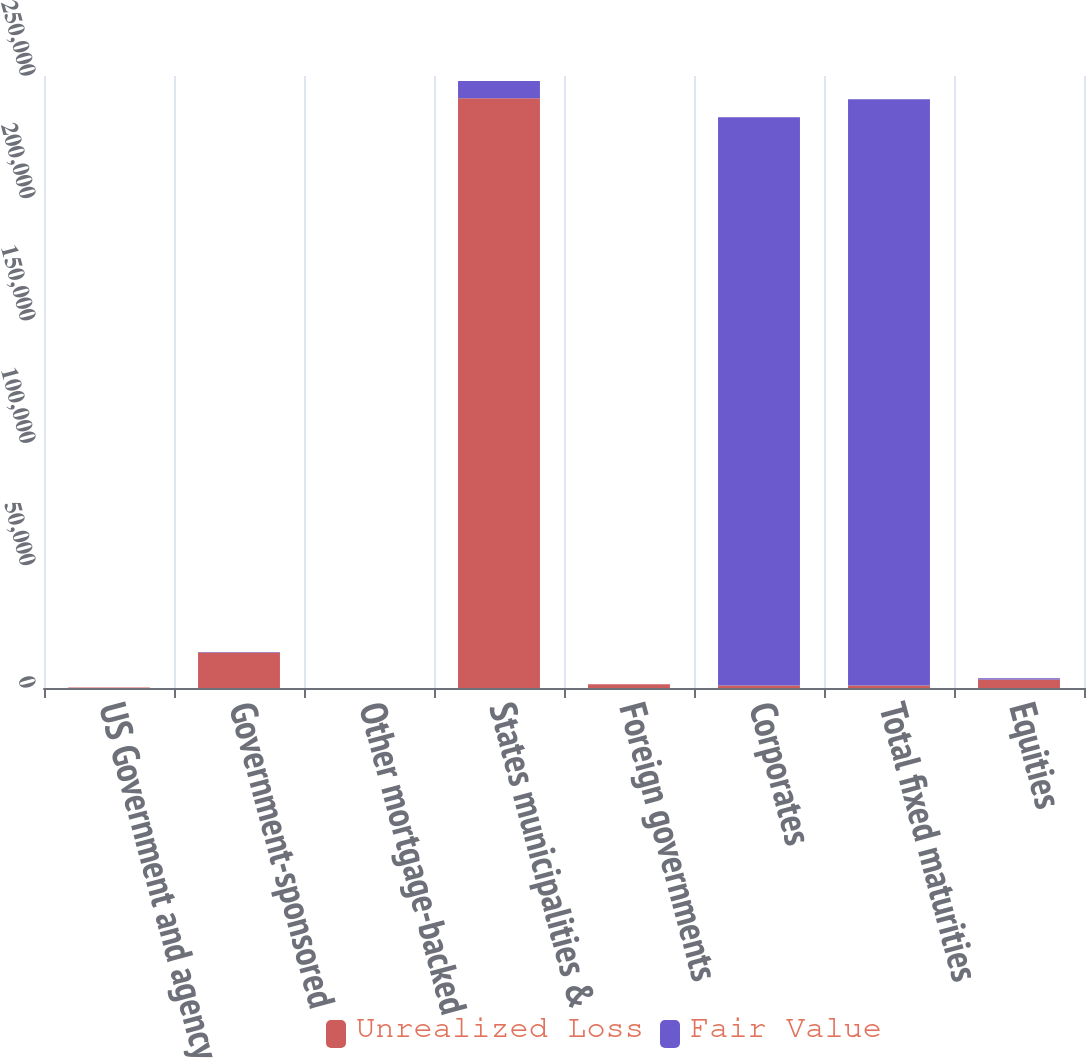Convert chart. <chart><loc_0><loc_0><loc_500><loc_500><stacked_bar_chart><ecel><fcel>US Government and agency<fcel>Government-sponsored<fcel>Other mortgage-backed<fcel>States municipalities &<fcel>Foreign governments<fcel>Corporates<fcel>Total fixed maturities<fcel>Equities<nl><fcel>Unrealized Loss<fcel>240<fcel>14467<fcel>0<fcel>240921<fcel>1482<fcel>1014<fcel>1014<fcel>3454<nl><fcel>Fair Value<fcel>1<fcel>278<fcel>0<fcel>6997<fcel>50<fcel>232184<fcel>239510<fcel>546<nl></chart> 